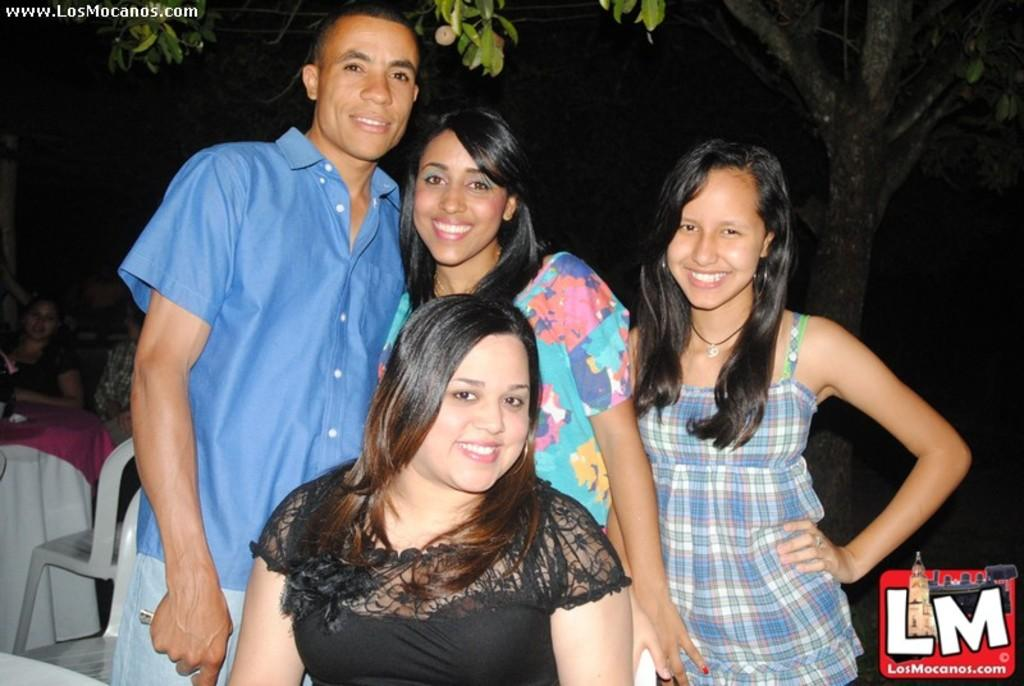How many people are standing in the image? There are two women and a man standing in the image. What is the woman in front of them doing? There is a woman sitting in front of them. What can be seen in the background of the image? There is a tree and people sitting in the background of the image. What type of debt is being discussed by the people in the image? There is no indication of any debt being discussed in the image; it features people standing and sitting. What office is visible in the background of the image? There is no office visible in the image; it features a tree and people sitting in the background. 